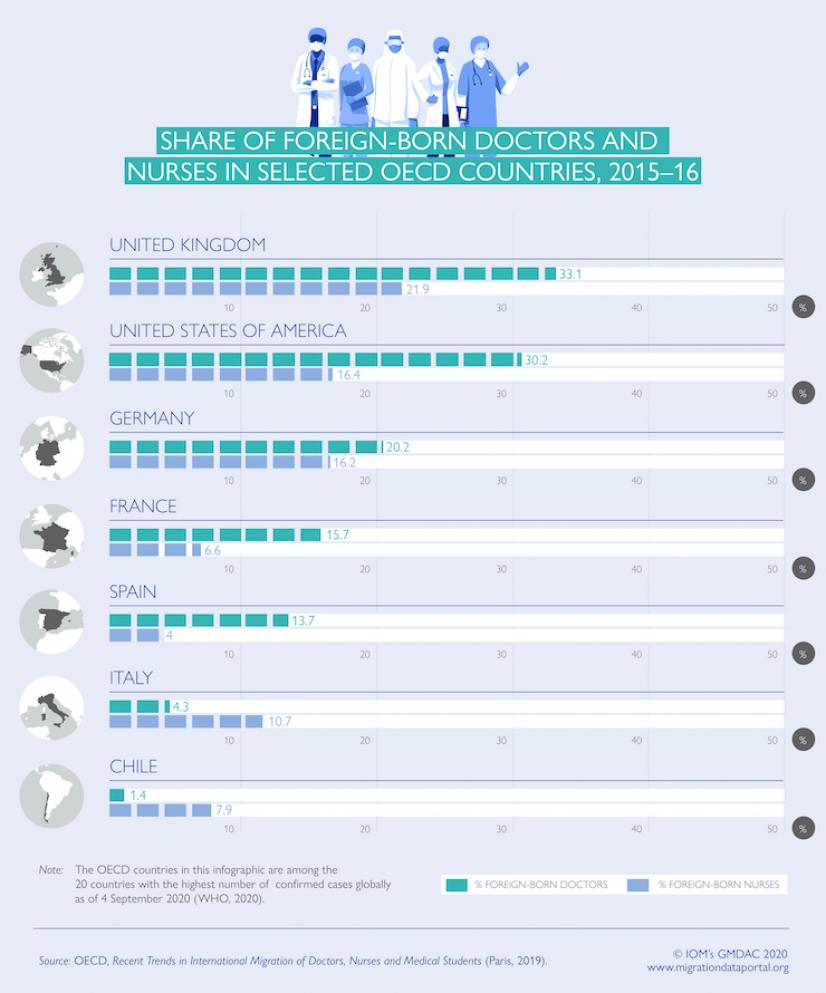Outline some significant characteristics in this image. The share of nurses in Spain and Italy, taken together, is 14.7%. The share of doctors in Germany and France, taken together, is 35.9%. In the United Kingdom and the United States, taken together, the share of doctors is approximately 63.3%. 